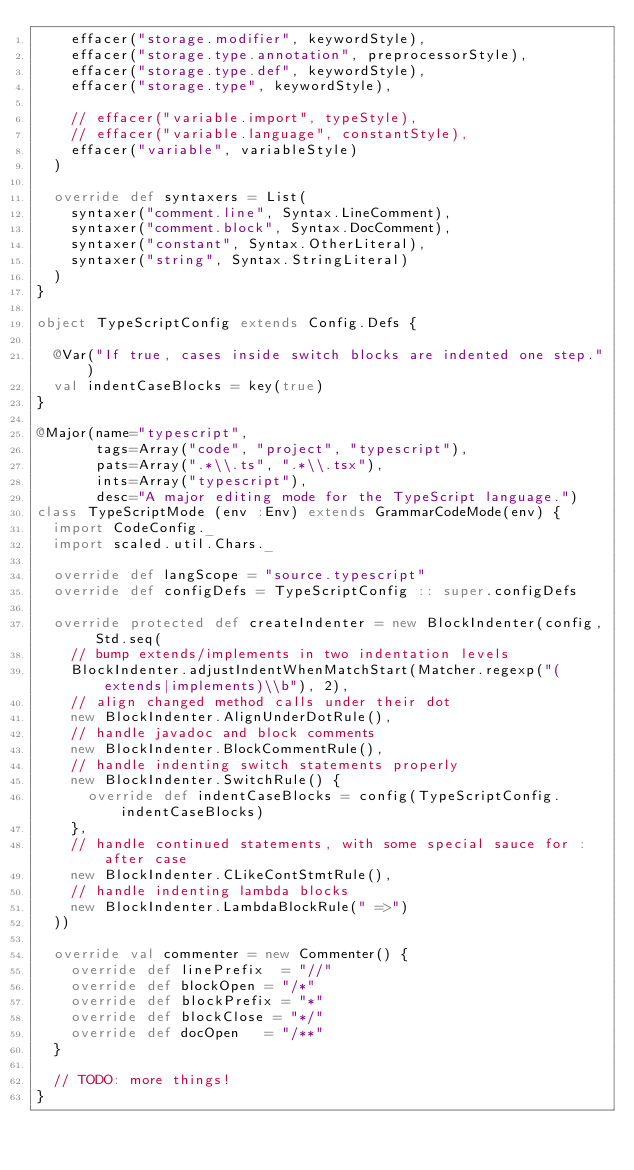Convert code to text. <code><loc_0><loc_0><loc_500><loc_500><_Scala_>    effacer("storage.modifier", keywordStyle),
    effacer("storage.type.annotation", preprocessorStyle),
    effacer("storage.type.def", keywordStyle),
    effacer("storage.type", keywordStyle),

    // effacer("variable.import", typeStyle),
    // effacer("variable.language", constantStyle),
    effacer("variable", variableStyle)
  )

  override def syntaxers = List(
    syntaxer("comment.line", Syntax.LineComment),
    syntaxer("comment.block", Syntax.DocComment),
    syntaxer("constant", Syntax.OtherLiteral),
    syntaxer("string", Syntax.StringLiteral)
  )
}

object TypeScriptConfig extends Config.Defs {

  @Var("If true, cases inside switch blocks are indented one step.")
  val indentCaseBlocks = key(true)
}

@Major(name="typescript",
       tags=Array("code", "project", "typescript"),
       pats=Array(".*\\.ts", ".*\\.tsx"),
       ints=Array("typescript"),
       desc="A major editing mode for the TypeScript language.")
class TypeScriptMode (env :Env) extends GrammarCodeMode(env) {
  import CodeConfig._
  import scaled.util.Chars._

  override def langScope = "source.typescript"
  override def configDefs = TypeScriptConfig :: super.configDefs

  override protected def createIndenter = new BlockIndenter(config, Std.seq(
    // bump extends/implements in two indentation levels
    BlockIndenter.adjustIndentWhenMatchStart(Matcher.regexp("(extends|implements)\\b"), 2),
    // align changed method calls under their dot
    new BlockIndenter.AlignUnderDotRule(),
    // handle javadoc and block comments
    new BlockIndenter.BlockCommentRule(),
    // handle indenting switch statements properly
    new BlockIndenter.SwitchRule() {
      override def indentCaseBlocks = config(TypeScriptConfig.indentCaseBlocks)
    },
    // handle continued statements, with some special sauce for : after case
    new BlockIndenter.CLikeContStmtRule(),
    // handle indenting lambda blocks
    new BlockIndenter.LambdaBlockRule(" =>")
  ))

  override val commenter = new Commenter() {
    override def linePrefix  = "//"
    override def blockOpen = "/*"
    override def blockPrefix = "*"
    override def blockClose = "*/"
    override def docOpen   = "/**"
  }

  // TODO: more things!
}
</code> 